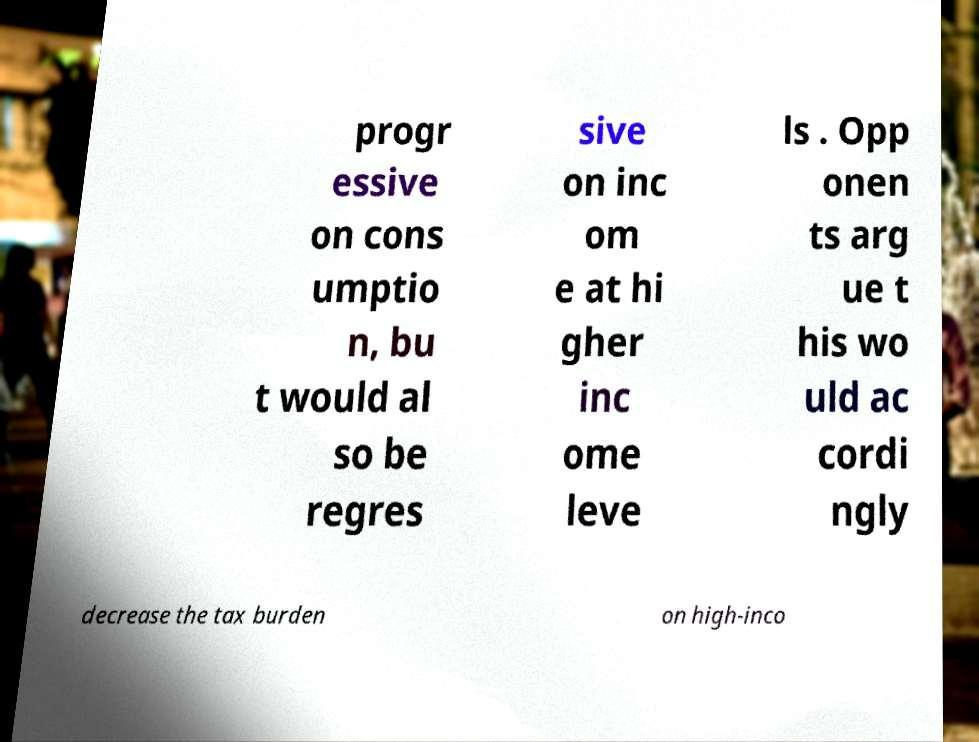Please read and relay the text visible in this image. What does it say? progr essive on cons umptio n, bu t would al so be regres sive on inc om e at hi gher inc ome leve ls . Opp onen ts arg ue t his wo uld ac cordi ngly decrease the tax burden on high-inco 